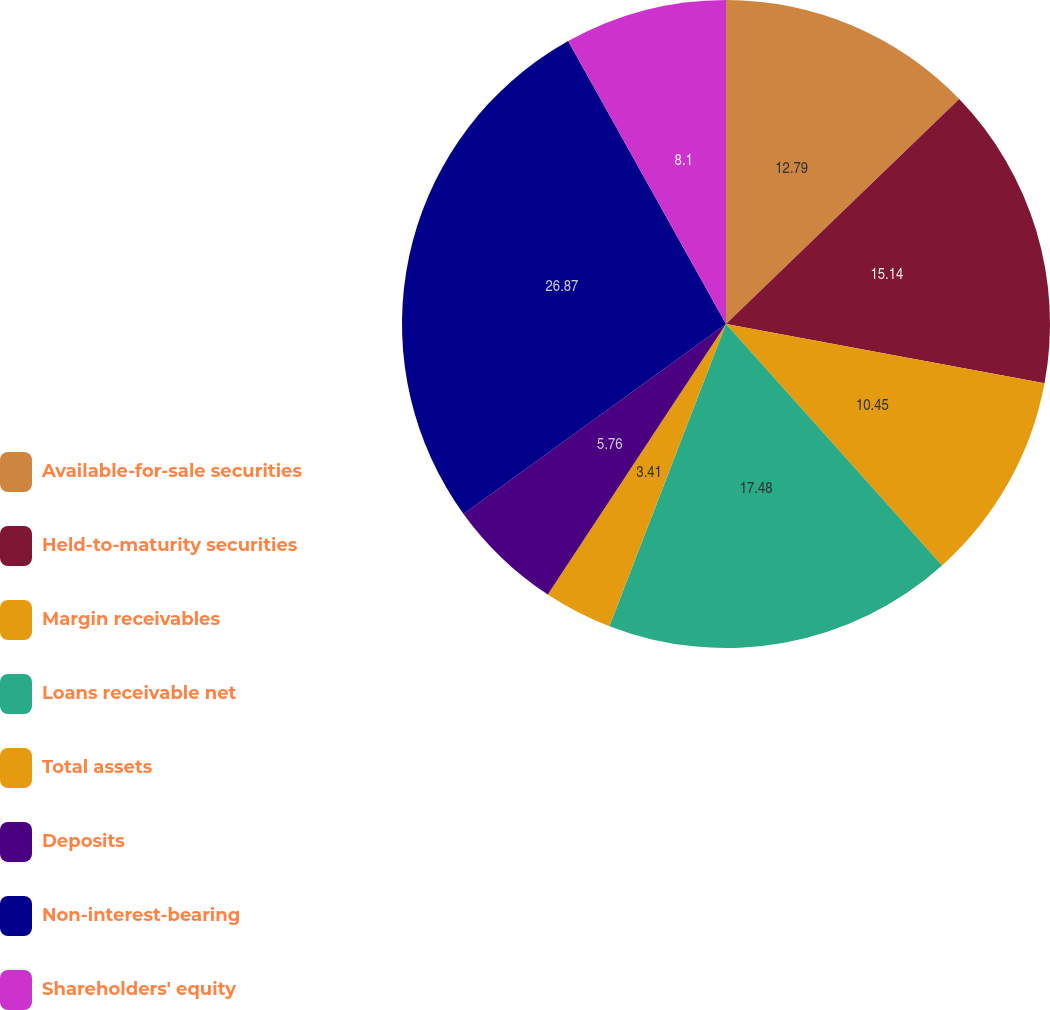Convert chart to OTSL. <chart><loc_0><loc_0><loc_500><loc_500><pie_chart><fcel>Available-for-sale securities<fcel>Held-to-maturity securities<fcel>Margin receivables<fcel>Loans receivable net<fcel>Total assets<fcel>Deposits<fcel>Non-interest-bearing<fcel>Shareholders' equity<nl><fcel>12.79%<fcel>15.14%<fcel>10.45%<fcel>17.48%<fcel>3.41%<fcel>5.76%<fcel>26.87%<fcel>8.1%<nl></chart> 